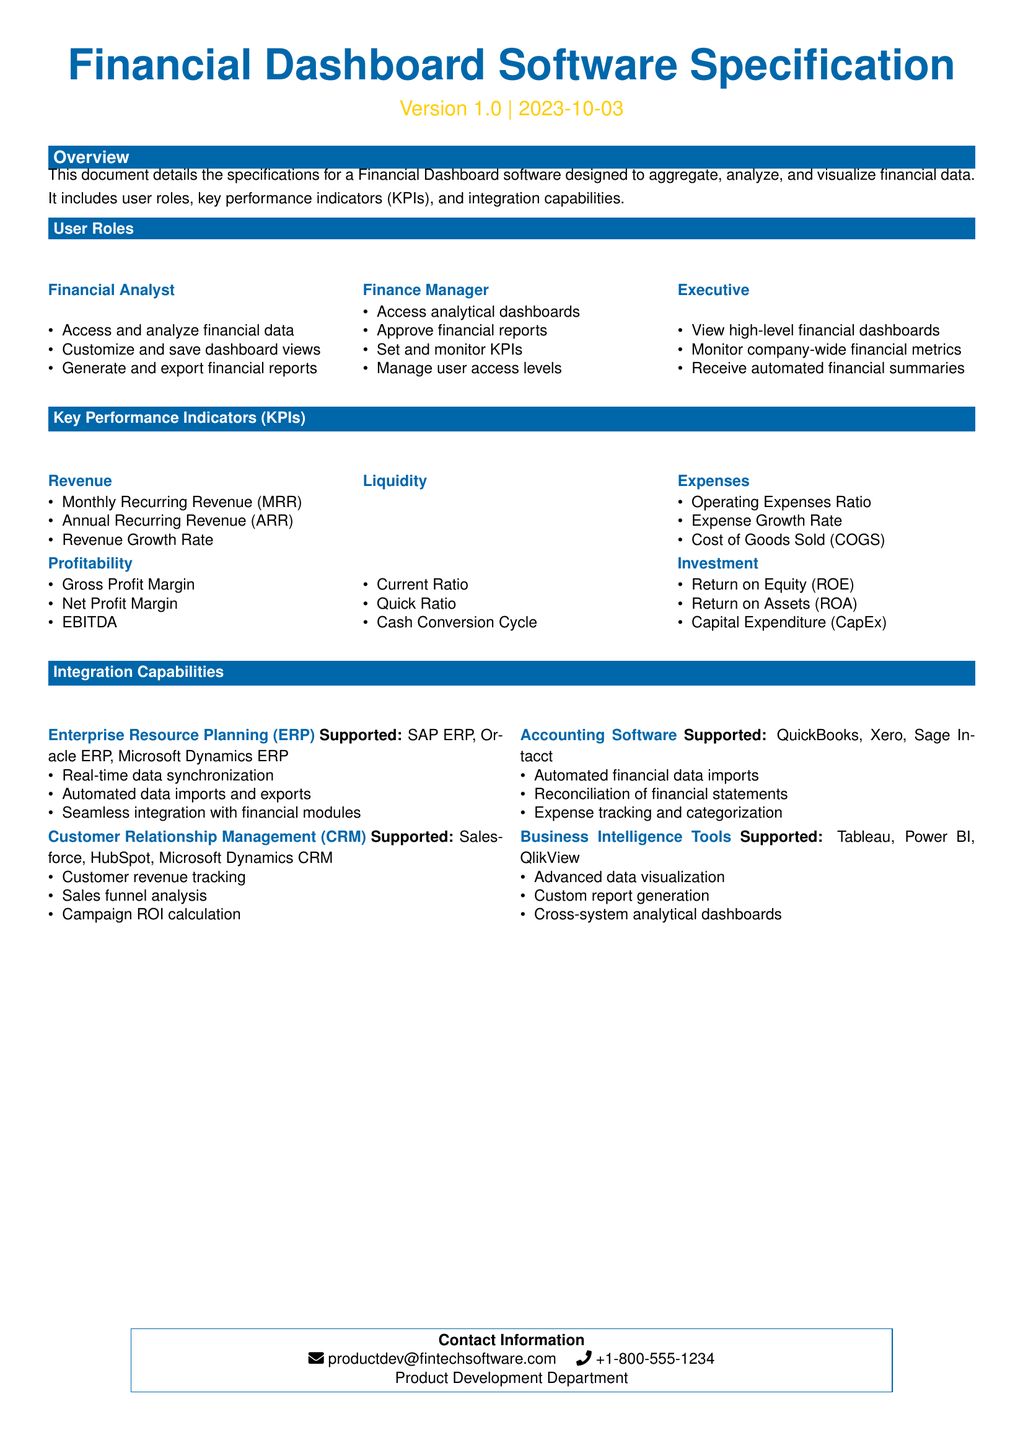What is the version of the software? The document specifies the software version as 1.0.
Answer: 1.0 What is the primary color used in the document? The primary color defined in the document is represented by the RGB value 0,103,171.
Answer: 0,103,171 Which user role can generate and export financial reports? The user role of Financial Analyst includes the capability to generate and export financial reports.
Answer: Financial Analyst What KPI measures profitability? The document lists Gross Profit Margin as one of the KPIs that measure profitability.
Answer: Gross Profit Margin How many user roles are described in the document? The document describes three distinct user roles: Financial Analyst, Finance Manager, and Executive.
Answer: 3 Which accounting software is supported for integration? The document lists QuickBooks, Xero, and Sage Intacct as supported accounting software for integration.
Answer: QuickBooks, Xero, Sage Intacct What KPI focuses on the revenue growth rate? Revenue Growth Rate is identified in the document under the KPI category for Revenue.
Answer: Revenue Growth Rate Which business intelligence tools are mentioned? The document mentions Tableau, Power BI, and QlikView as supported business intelligence tools.
Answer: Tableau, Power BI, QlikView Who should be contacted for product development inquiries? The document provides the email productdev@fintechsoftware.com for product development inquiries.
Answer: productdev@fintechsoftware.com 